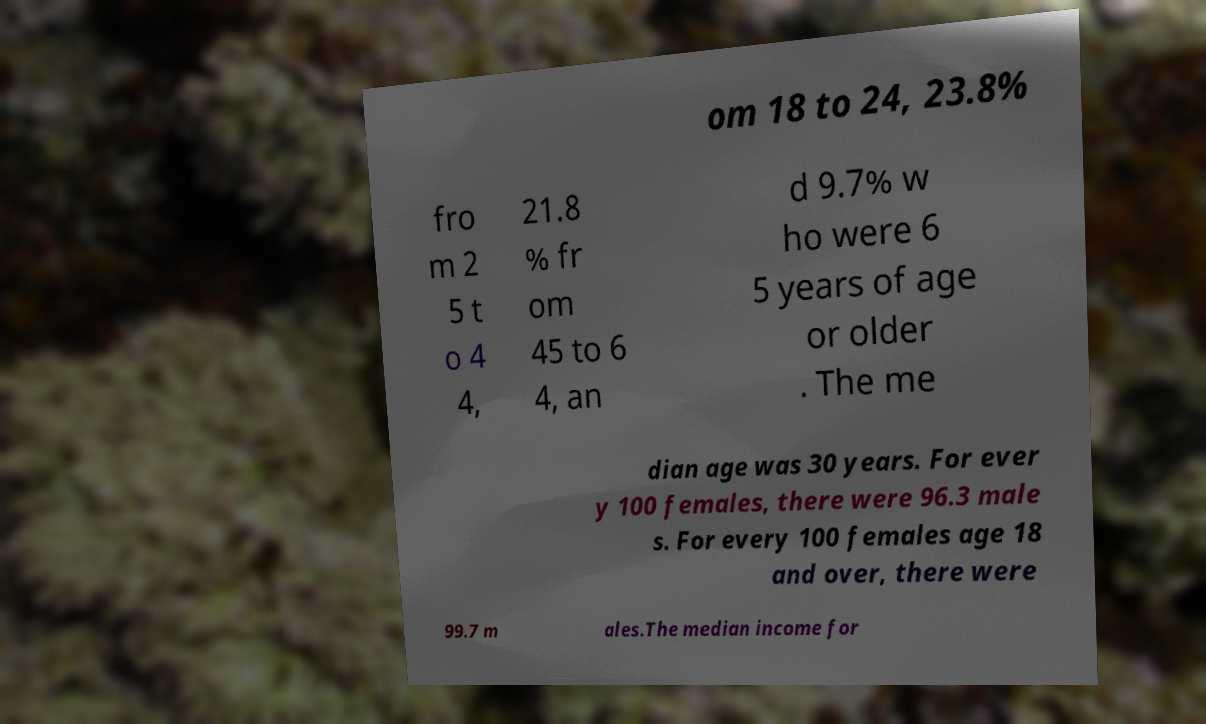Please identify and transcribe the text found in this image. om 18 to 24, 23.8% fro m 2 5 t o 4 4, 21.8 % fr om 45 to 6 4, an d 9.7% w ho were 6 5 years of age or older . The me dian age was 30 years. For ever y 100 females, there were 96.3 male s. For every 100 females age 18 and over, there were 99.7 m ales.The median income for 